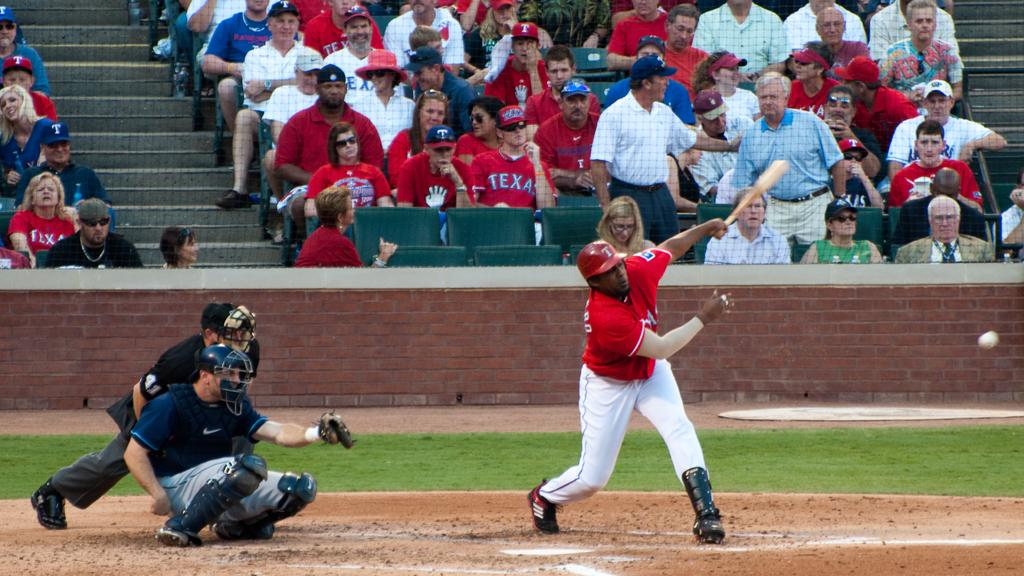<image>
Give a short and clear explanation of the subsequent image. Baseball player swinging his bat to hit the ball and is on team Texas. 